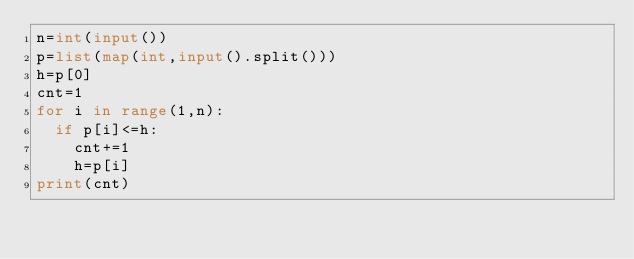Convert code to text. <code><loc_0><loc_0><loc_500><loc_500><_Python_>n=int(input())
p=list(map(int,input().split()))
h=p[0]
cnt=1
for i in range(1,n):
  if p[i]<=h:
    cnt+=1
    h=p[i]
print(cnt)</code> 